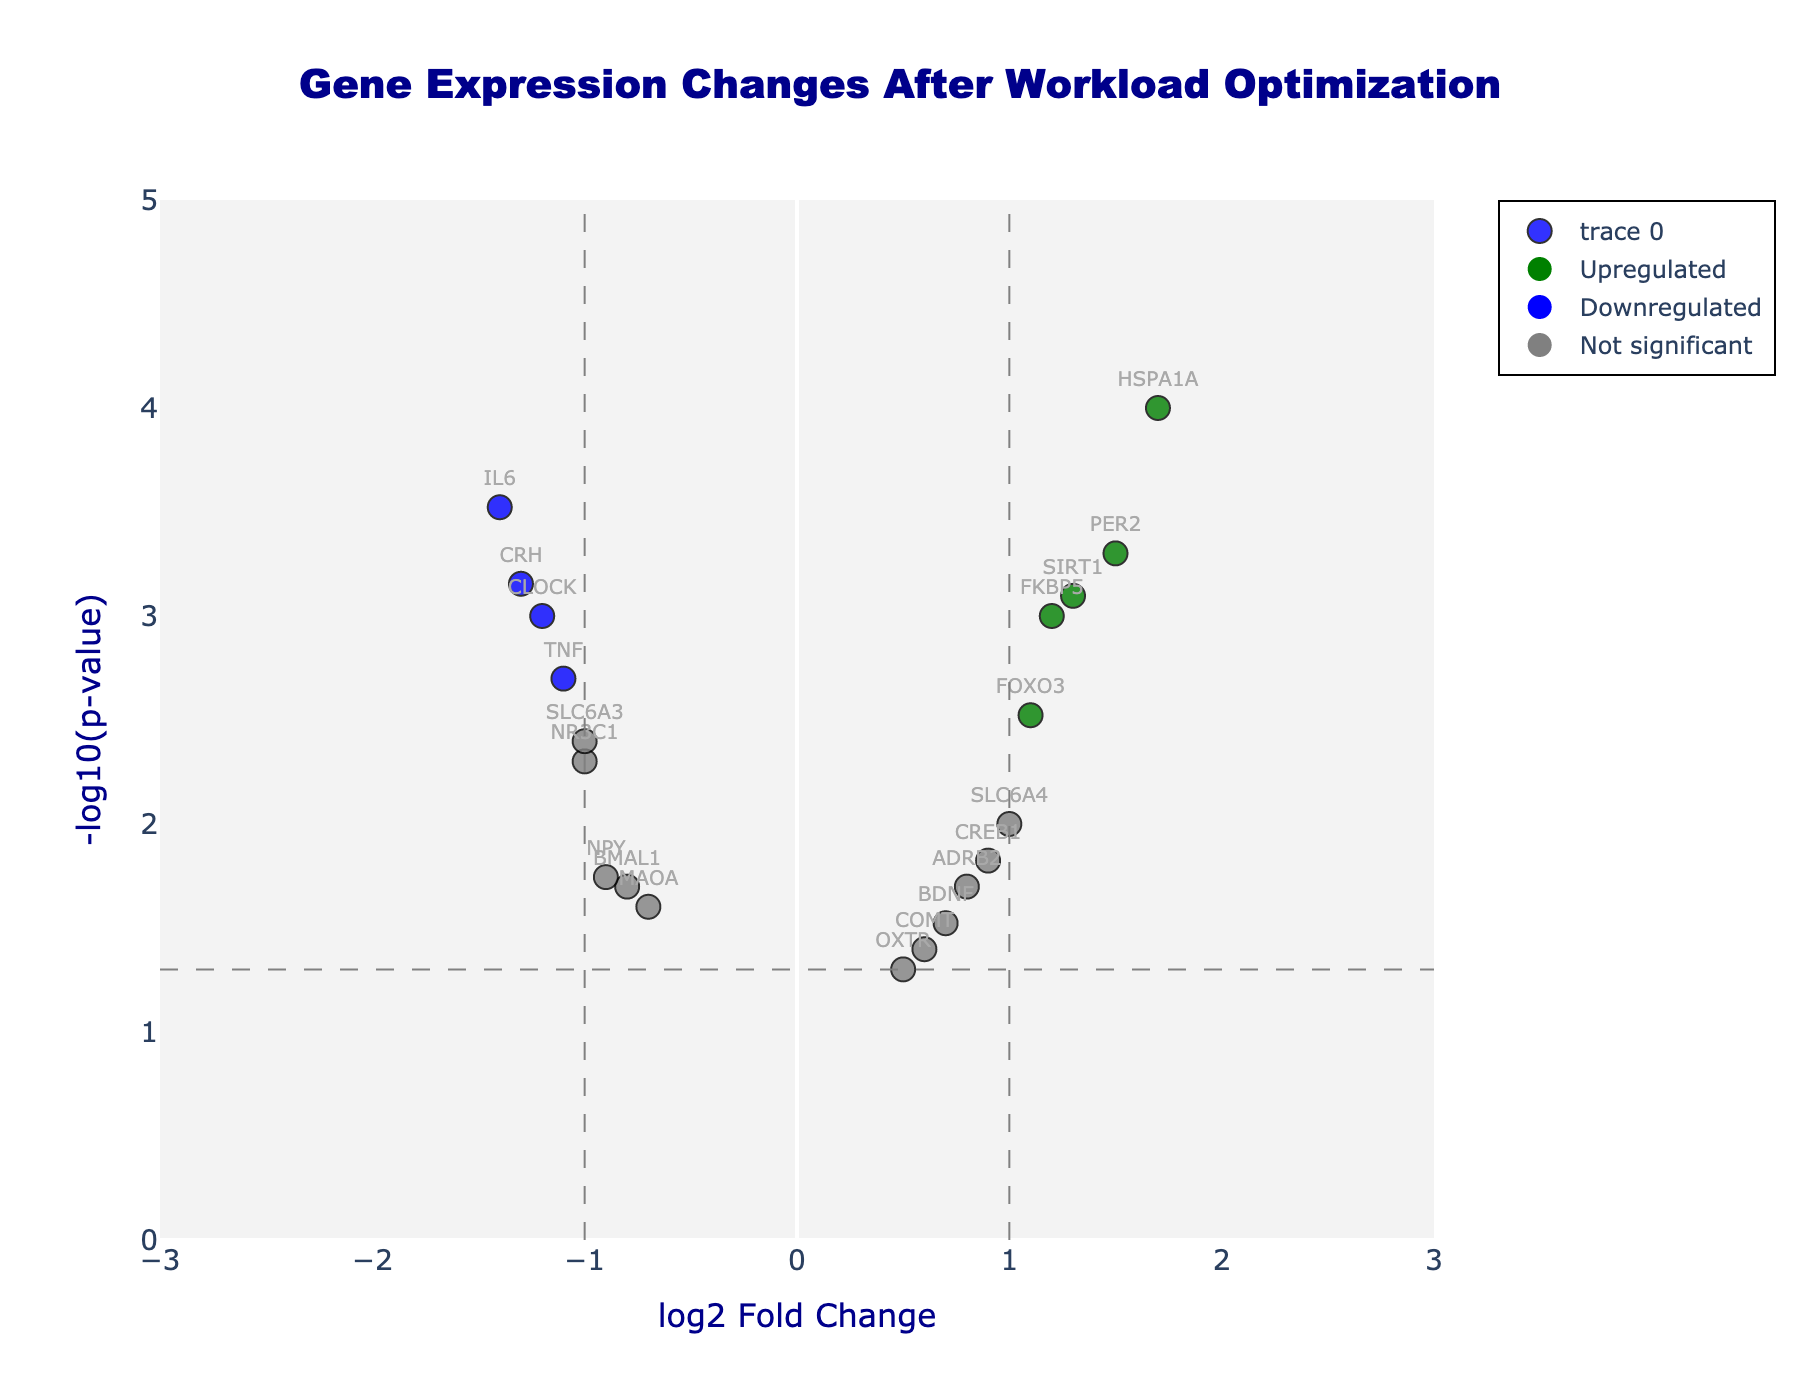How many genes showed significant upregulation after workload optimization? Significant upregulation is represented by genes with log2 Fold Change greater than 1 and p-value less than 0.05, shown in green. From the plot, we observe 5 green points.
Answer: 5 Which gene has the highest fold change and what is its value? The gene with the highest fold change has the highest absolute value on the x-axis. Here, HSPA1A has the highest log2 Fold Change of 1.7.
Answer: HSPA1A, 1.7 Are there any genes that were not significantly affected by the workload optimization? Genes that are not significantly affected are represented in grey. From the plot, we observe genes like OXTR and COMT that fall in this category.
Answer: Yes Which genes have a log2 Fold Change less than -1? Genes with log2 Fold Change less than -1 are all left to the dashed vertical line at -1. These genes are CLOCK, IL6, CRH, and SLC6A3.
Answer: CLOCK, IL6, CRH, SLC6A3 What is the overall title of the plot? The plot's title is located at the top and centered. It says, "Gene Expression Changes After Workload Optimization".
Answer: Gene Expression Changes After Workload Optimization How many genes are shown in the plot? Counting the total number of points (genes) displayed in the plot. These are 19 points based on the data provided.
Answer: 19 Which gene has the highest p-value and what is its value? The value of -log10(p-value) is directly related to the y-axis. The lowest point on the y-axis indicates the highest p-value, which is OXTR with a p-value of 0.05.
Answer: OXTR, 0.05 Compare the expression changes of genes FOXO3 and TNF. Which one is more upregulated? To determine upregulation, we compare the log2 Fold Change values of both genes. FOXO3 has a log2 Fold Change of 1.1, while TNF is -1.1. Therefore, FOXO3 is more upregulated.
Answer: FOXO3 How is statistical significance indicated visually in the plot? Statistical significance in the plot is indicated by color and position relative to the horizontal dashed line at -log10(0.05): genes above this line are significant. Larger color categories (green and blue) also indicate significant changes.
Answer: By color and position relative to the horizontal dashed line What are the thresholds for log2 Fold Change and p-value used in this plot to determine significance? The thresholds can be inferred from the position of the dashed lines: for log2 Fold Change it is ±1, and for p-value it is 0.05 as indicated by the horizontal dashed line (i.e., the y-axis value of 1.3).
Answer: ±1 for log2 Fold Change, 0.05 for p-value 